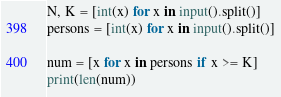<code> <loc_0><loc_0><loc_500><loc_500><_Python_>N, K = [int(x) for x in input().split()]
persons = [int(x) for x in input().split()]

num = [x for x in persons if x >= K]
print(len(num))</code> 